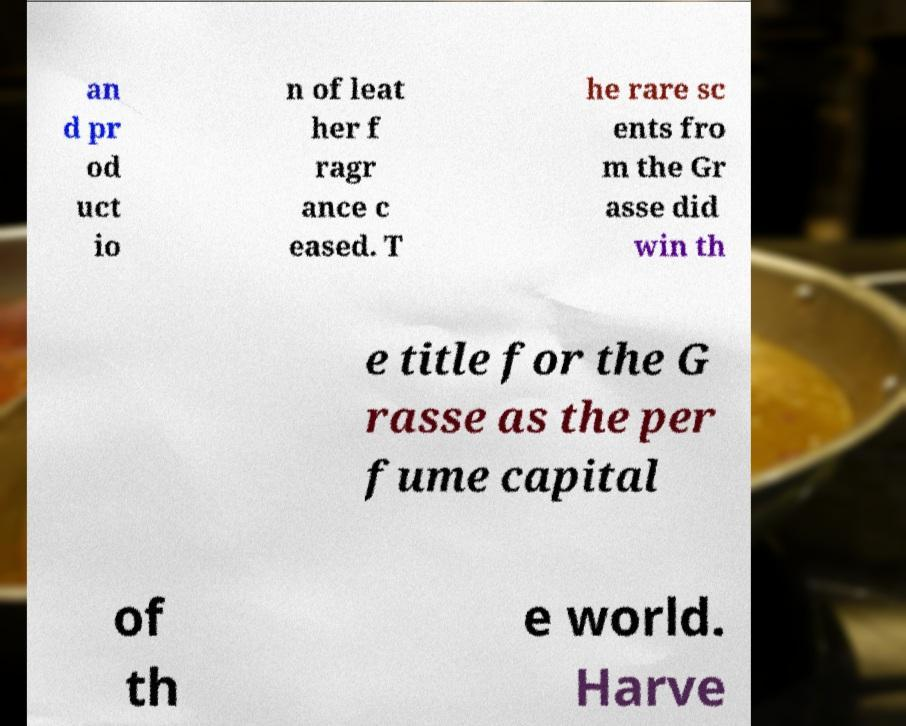I need the written content from this picture converted into text. Can you do that? an d pr od uct io n of leat her f ragr ance c eased. T he rare sc ents fro m the Gr asse did win th e title for the G rasse as the per fume capital of th e world. Harve 